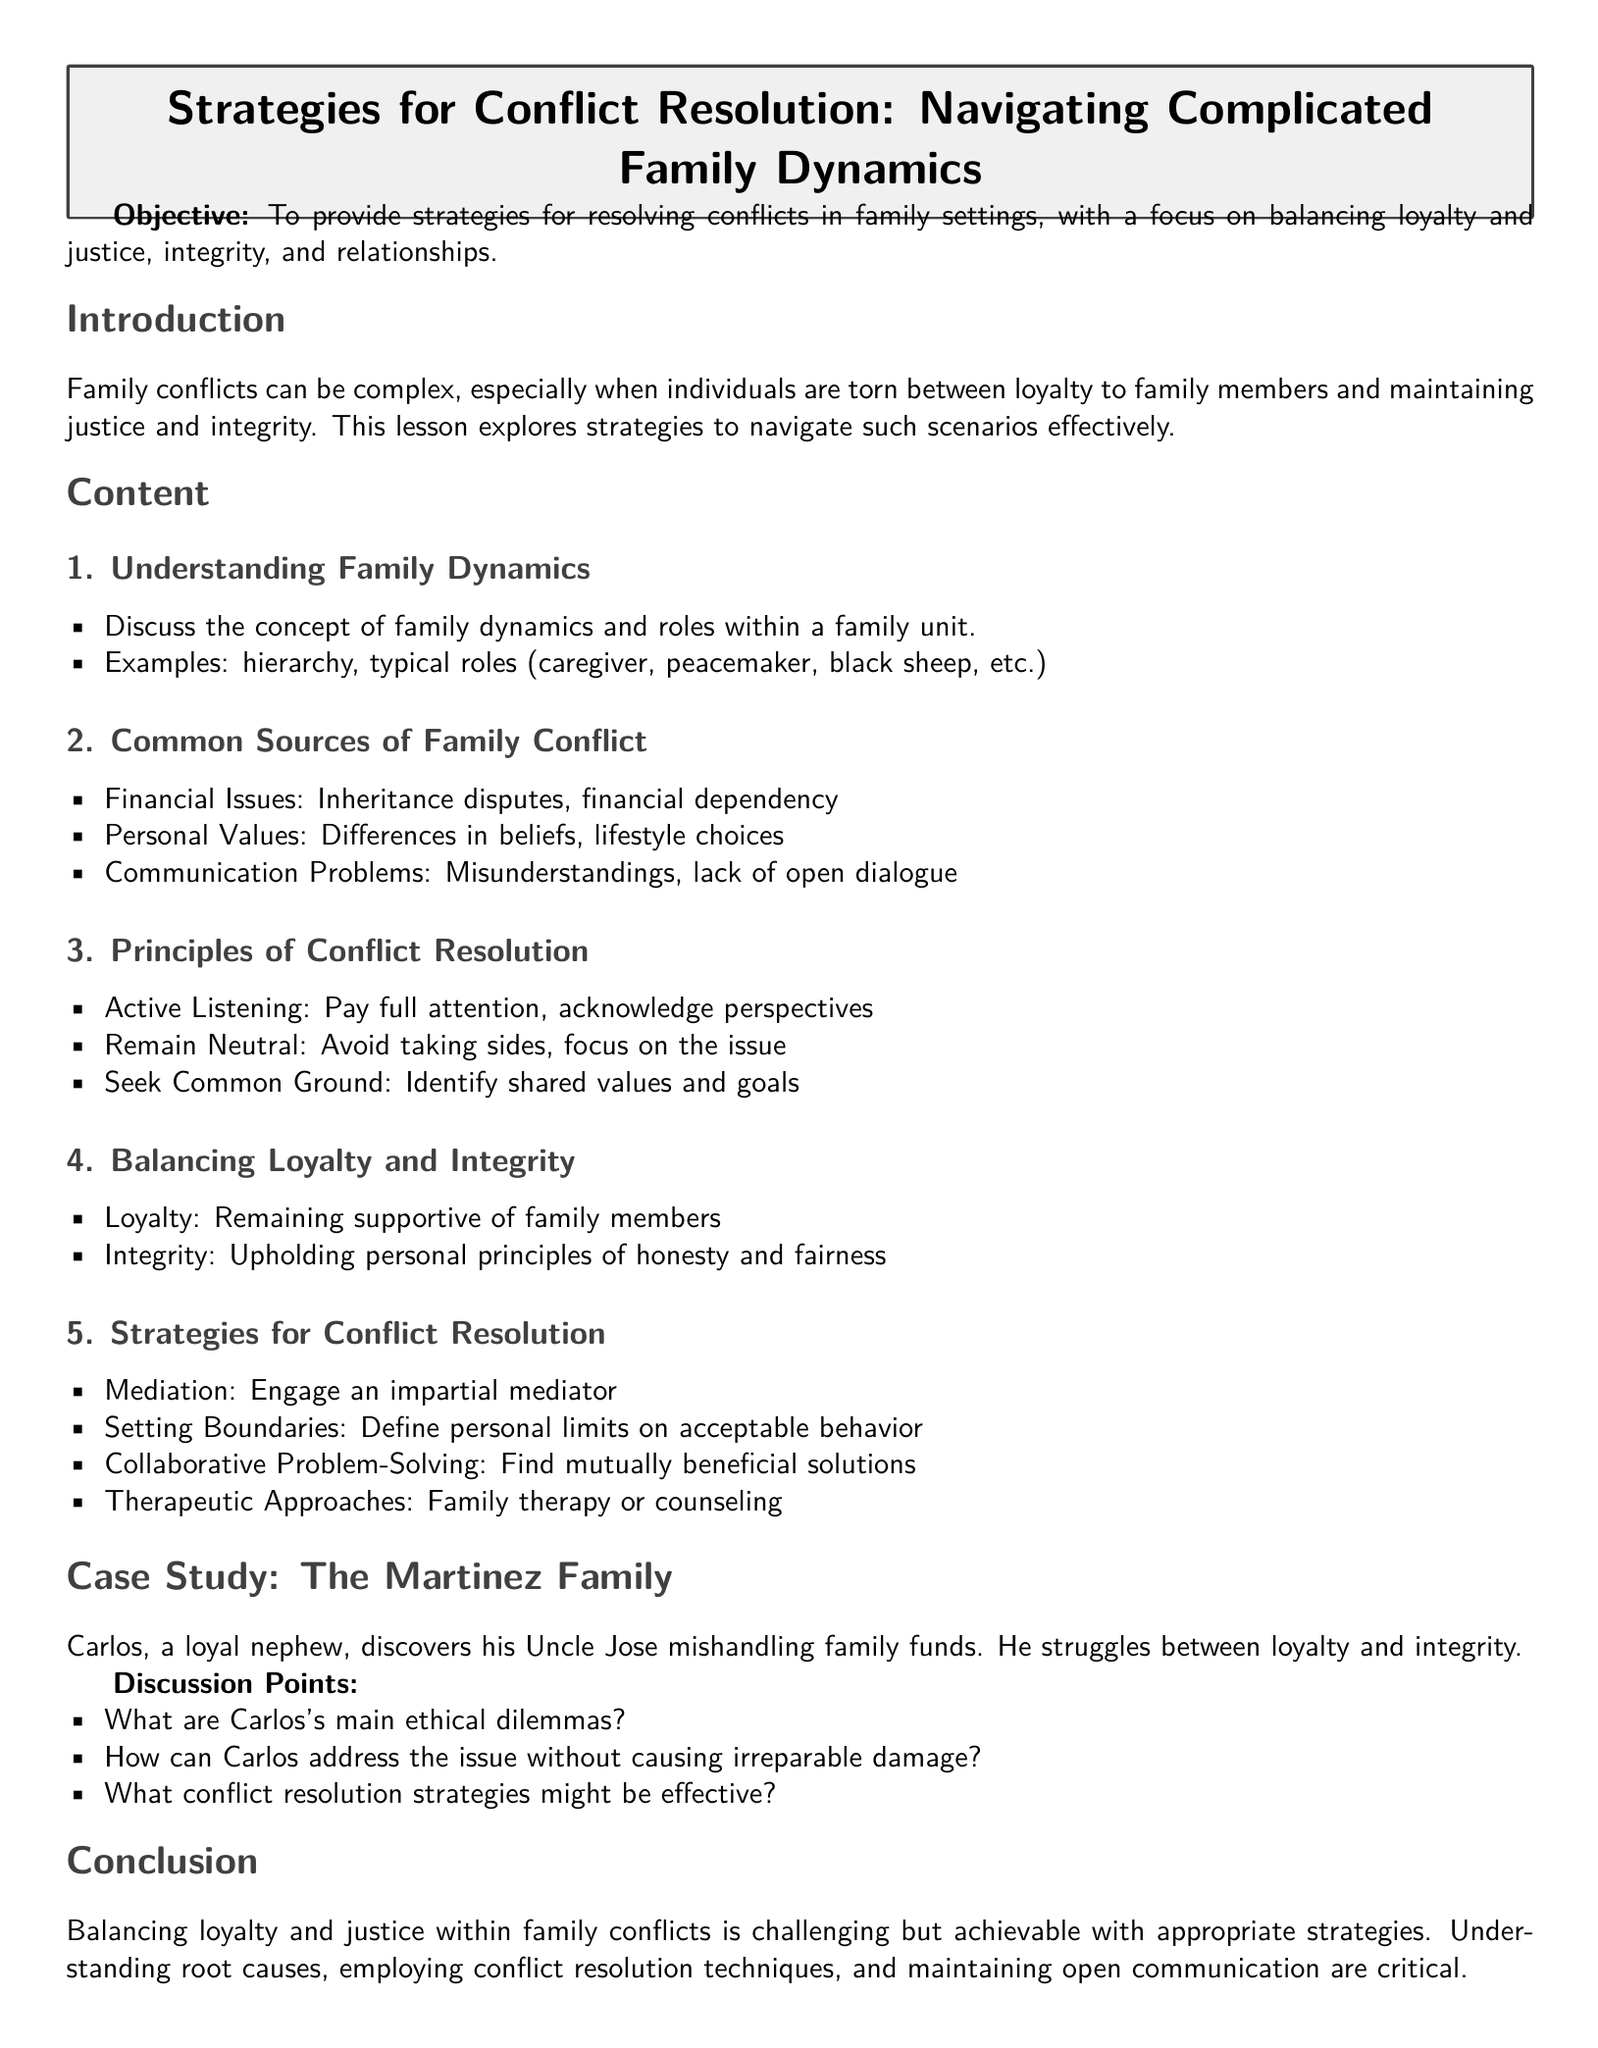What is the main objective of the lesson? The objective outlines the purpose of the lesson, which is to provide strategies for resolving conflicts in family settings.
Answer: To provide strategies for resolving conflicts in family settings What is one common source of family conflict mentioned? The document lists several sources of family conflict, including financial issues.
Answer: Financial Issues What is the first principle of conflict resolution? The principles of conflict resolution are listed, with active listening being the first item.
Answer: Active Listening What dilemma does Carlos face in the case study? The case study describes Carlos's struggle between loyalty to his uncle and the need for integrity.
Answer: Loyalty and integrity Which strategy involves seeking a neutral party? The document outlines mediation as a strategy that involves bringing in an impartial mediator.
Answer: Mediation What does the lesson emphasize about balancing family dynamics? The conclusion states that balancing loyalty and justice is challenging but achievable.
Answer: Challenging but achievable 